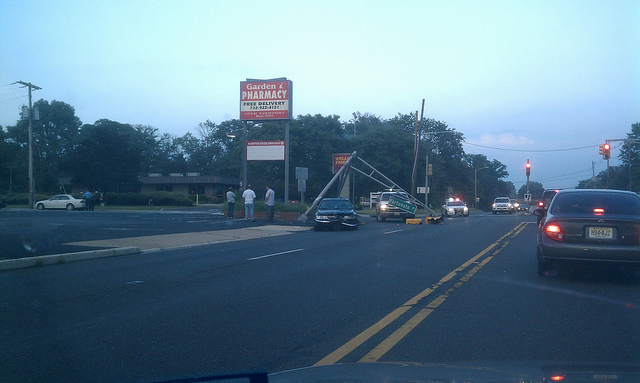Identify the text contained in this image. Garden PHARMACY DELIVERY 